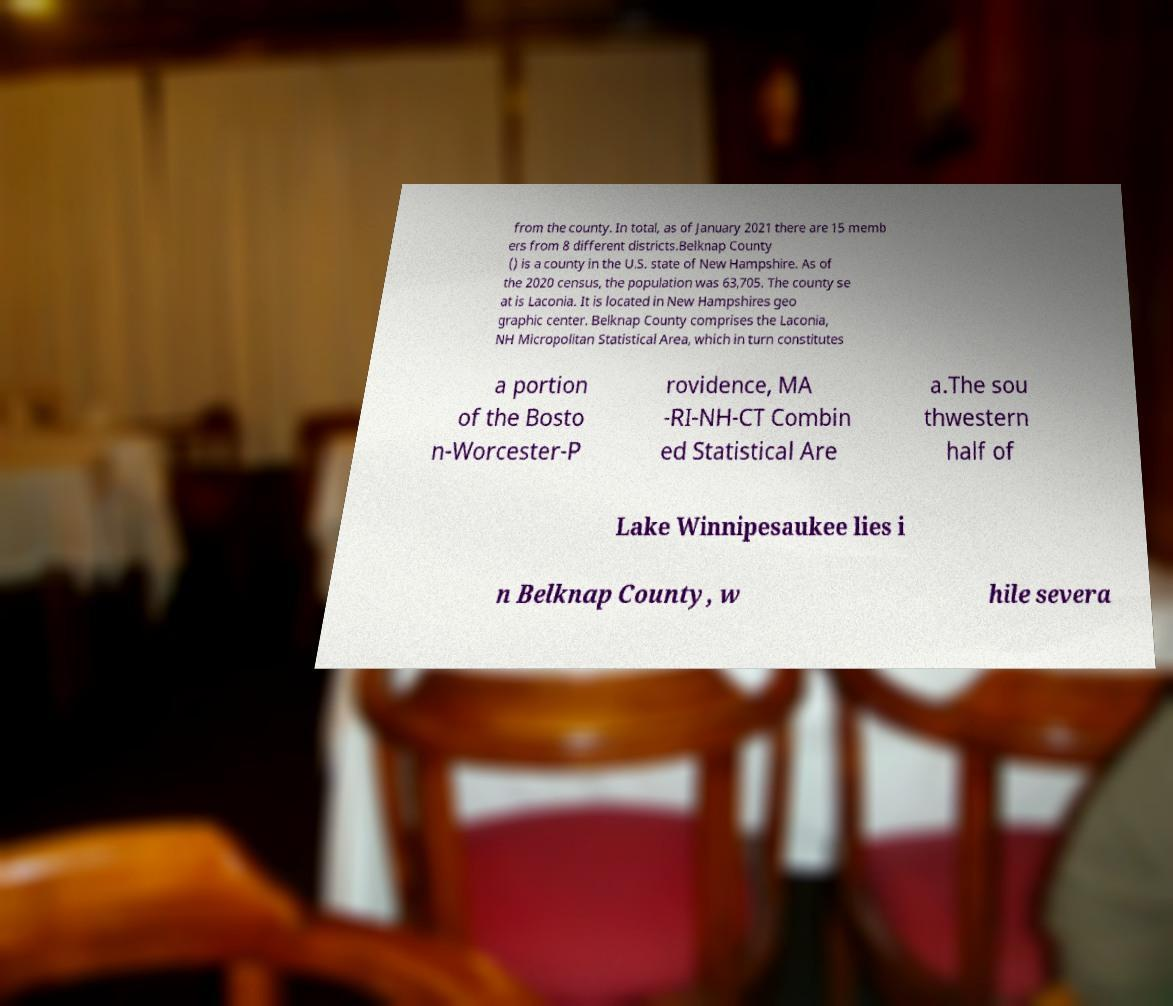Please identify and transcribe the text found in this image. from the county. In total, as of January 2021 there are 15 memb ers from 8 different districts.Belknap County () is a county in the U.S. state of New Hampshire. As of the 2020 census, the population was 63,705. The county se at is Laconia. It is located in New Hampshires geo graphic center. Belknap County comprises the Laconia, NH Micropolitan Statistical Area, which in turn constitutes a portion of the Bosto n-Worcester-P rovidence, MA -RI-NH-CT Combin ed Statistical Are a.The sou thwestern half of Lake Winnipesaukee lies i n Belknap County, w hile severa 